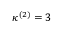<formula> <loc_0><loc_0><loc_500><loc_500>\kappa ^ { ( 2 ) } = 3</formula> 